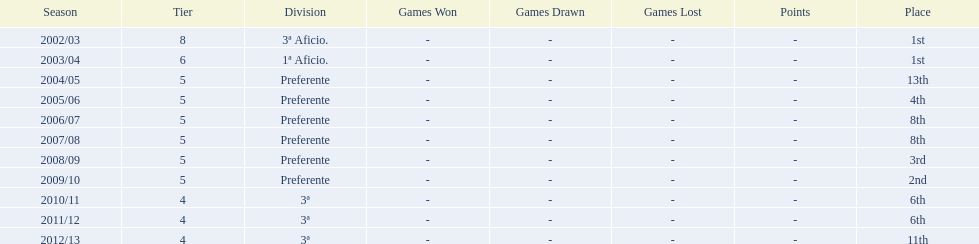What place was 1a aficio and 3a aficio? 1st. 